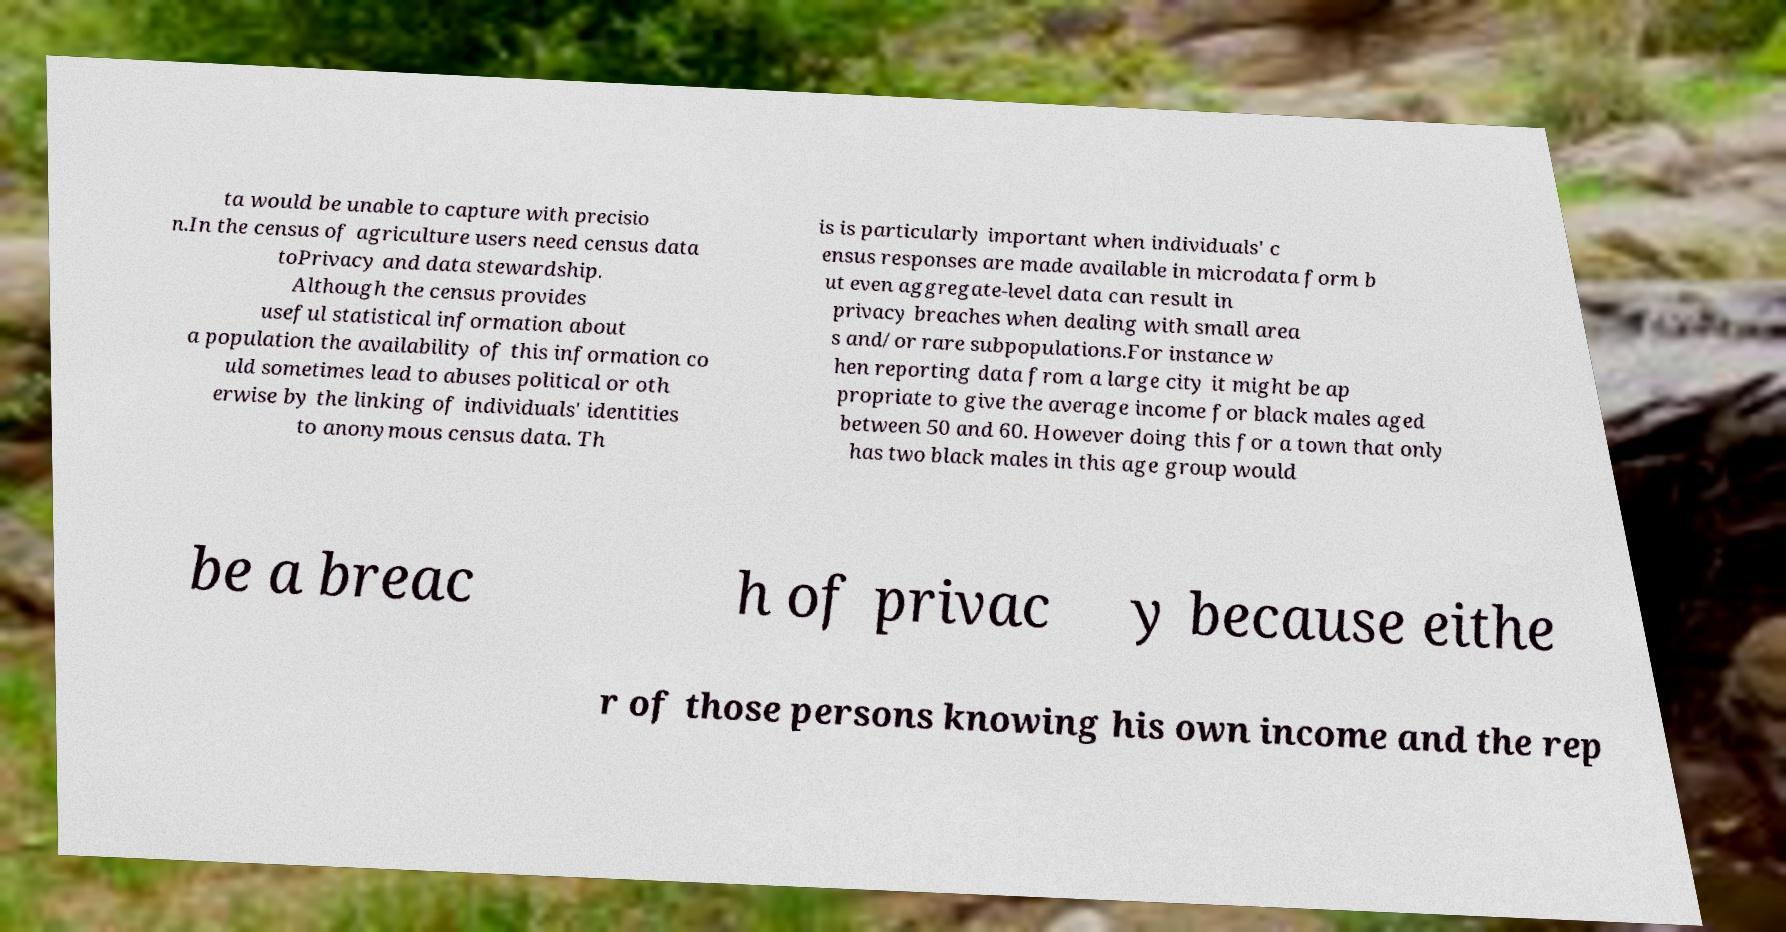Could you assist in decoding the text presented in this image and type it out clearly? ta would be unable to capture with precisio n.In the census of agriculture users need census data toPrivacy and data stewardship. Although the census provides useful statistical information about a population the availability of this information co uld sometimes lead to abuses political or oth erwise by the linking of individuals' identities to anonymous census data. Th is is particularly important when individuals' c ensus responses are made available in microdata form b ut even aggregate-level data can result in privacy breaches when dealing with small area s and/or rare subpopulations.For instance w hen reporting data from a large city it might be ap propriate to give the average income for black males aged between 50 and 60. However doing this for a town that only has two black males in this age group would be a breac h of privac y because eithe r of those persons knowing his own income and the rep 